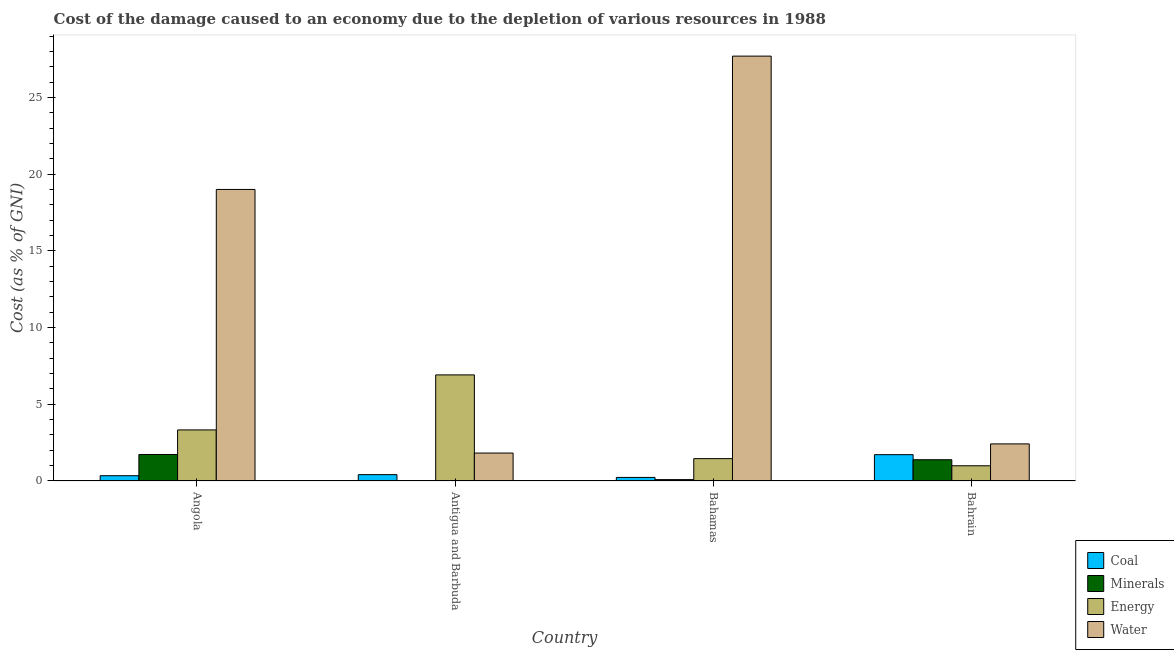How many different coloured bars are there?
Give a very brief answer. 4. How many groups of bars are there?
Keep it short and to the point. 4. Are the number of bars per tick equal to the number of legend labels?
Make the answer very short. Yes. Are the number of bars on each tick of the X-axis equal?
Ensure brevity in your answer.  Yes. What is the label of the 3rd group of bars from the left?
Your response must be concise. Bahamas. What is the cost of damage due to depletion of energy in Antigua and Barbuda?
Offer a very short reply. 6.92. Across all countries, what is the maximum cost of damage due to depletion of energy?
Offer a terse response. 6.92. Across all countries, what is the minimum cost of damage due to depletion of minerals?
Make the answer very short. 0.02. In which country was the cost of damage due to depletion of minerals maximum?
Your response must be concise. Angola. In which country was the cost of damage due to depletion of coal minimum?
Your answer should be compact. Bahamas. What is the total cost of damage due to depletion of energy in the graph?
Keep it short and to the point. 12.7. What is the difference between the cost of damage due to depletion of water in Angola and that in Bahamas?
Your answer should be compact. -8.69. What is the difference between the cost of damage due to depletion of minerals in Antigua and Barbuda and the cost of damage due to depletion of water in Bahamas?
Offer a terse response. -27.67. What is the average cost of damage due to depletion of energy per country?
Your answer should be compact. 3.17. What is the difference between the cost of damage due to depletion of energy and cost of damage due to depletion of coal in Angola?
Your answer should be compact. 2.99. In how many countries, is the cost of damage due to depletion of water greater than 23 %?
Make the answer very short. 1. What is the ratio of the cost of damage due to depletion of minerals in Angola to that in Bahrain?
Your response must be concise. 1.25. Is the cost of damage due to depletion of minerals in Angola less than that in Bahrain?
Ensure brevity in your answer.  No. What is the difference between the highest and the second highest cost of damage due to depletion of energy?
Your response must be concise. 3.59. What is the difference between the highest and the lowest cost of damage due to depletion of water?
Make the answer very short. 25.88. Is the sum of the cost of damage due to depletion of coal in Angola and Bahrain greater than the maximum cost of damage due to depletion of water across all countries?
Your answer should be compact. No. What does the 1st bar from the left in Antigua and Barbuda represents?
Your response must be concise. Coal. What does the 3rd bar from the right in Angola represents?
Keep it short and to the point. Minerals. Is it the case that in every country, the sum of the cost of damage due to depletion of coal and cost of damage due to depletion of minerals is greater than the cost of damage due to depletion of energy?
Ensure brevity in your answer.  No. How many countries are there in the graph?
Keep it short and to the point. 4. Does the graph contain any zero values?
Provide a short and direct response. No. How many legend labels are there?
Your answer should be compact. 4. How are the legend labels stacked?
Offer a terse response. Vertical. What is the title of the graph?
Provide a succinct answer. Cost of the damage caused to an economy due to the depletion of various resources in 1988 . Does "UNAIDS" appear as one of the legend labels in the graph?
Keep it short and to the point. No. What is the label or title of the Y-axis?
Provide a succinct answer. Cost (as % of GNI). What is the Cost (as % of GNI) in Coal in Angola?
Give a very brief answer. 0.34. What is the Cost (as % of GNI) in Minerals in Angola?
Offer a terse response. 1.73. What is the Cost (as % of GNI) in Energy in Angola?
Offer a terse response. 3.33. What is the Cost (as % of GNI) in Water in Angola?
Provide a succinct answer. 19.01. What is the Cost (as % of GNI) of Coal in Antigua and Barbuda?
Keep it short and to the point. 0.41. What is the Cost (as % of GNI) of Minerals in Antigua and Barbuda?
Your response must be concise. 0.02. What is the Cost (as % of GNI) in Energy in Antigua and Barbuda?
Your answer should be compact. 6.92. What is the Cost (as % of GNI) of Water in Antigua and Barbuda?
Give a very brief answer. 1.82. What is the Cost (as % of GNI) of Coal in Bahamas?
Keep it short and to the point. 0.23. What is the Cost (as % of GNI) of Minerals in Bahamas?
Provide a succinct answer. 0.09. What is the Cost (as % of GNI) in Energy in Bahamas?
Ensure brevity in your answer.  1.46. What is the Cost (as % of GNI) of Water in Bahamas?
Ensure brevity in your answer.  27.7. What is the Cost (as % of GNI) of Coal in Bahrain?
Make the answer very short. 1.72. What is the Cost (as % of GNI) in Minerals in Bahrain?
Provide a succinct answer. 1.39. What is the Cost (as % of GNI) of Energy in Bahrain?
Your response must be concise. 0.99. What is the Cost (as % of GNI) in Water in Bahrain?
Provide a succinct answer. 2.42. Across all countries, what is the maximum Cost (as % of GNI) in Coal?
Your response must be concise. 1.72. Across all countries, what is the maximum Cost (as % of GNI) of Minerals?
Offer a very short reply. 1.73. Across all countries, what is the maximum Cost (as % of GNI) of Energy?
Make the answer very short. 6.92. Across all countries, what is the maximum Cost (as % of GNI) of Water?
Keep it short and to the point. 27.7. Across all countries, what is the minimum Cost (as % of GNI) of Coal?
Your response must be concise. 0.23. Across all countries, what is the minimum Cost (as % of GNI) of Minerals?
Your answer should be very brief. 0.02. Across all countries, what is the minimum Cost (as % of GNI) of Energy?
Ensure brevity in your answer.  0.99. Across all countries, what is the minimum Cost (as % of GNI) of Water?
Ensure brevity in your answer.  1.82. What is the total Cost (as % of GNI) of Coal in the graph?
Ensure brevity in your answer.  2.71. What is the total Cost (as % of GNI) in Minerals in the graph?
Provide a succinct answer. 3.23. What is the total Cost (as % of GNI) of Energy in the graph?
Your answer should be compact. 12.7. What is the total Cost (as % of GNI) in Water in the graph?
Your response must be concise. 50.94. What is the difference between the Cost (as % of GNI) in Coal in Angola and that in Antigua and Barbuda?
Offer a terse response. -0.07. What is the difference between the Cost (as % of GNI) of Minerals in Angola and that in Antigua and Barbuda?
Provide a succinct answer. 1.7. What is the difference between the Cost (as % of GNI) of Energy in Angola and that in Antigua and Barbuda?
Provide a succinct answer. -3.59. What is the difference between the Cost (as % of GNI) in Water in Angola and that in Antigua and Barbuda?
Give a very brief answer. 17.18. What is the difference between the Cost (as % of GNI) of Coal in Angola and that in Bahamas?
Your answer should be very brief. 0.11. What is the difference between the Cost (as % of GNI) in Minerals in Angola and that in Bahamas?
Offer a very short reply. 1.64. What is the difference between the Cost (as % of GNI) of Energy in Angola and that in Bahamas?
Keep it short and to the point. 1.87. What is the difference between the Cost (as % of GNI) in Water in Angola and that in Bahamas?
Provide a succinct answer. -8.69. What is the difference between the Cost (as % of GNI) in Coal in Angola and that in Bahrain?
Offer a very short reply. -1.37. What is the difference between the Cost (as % of GNI) of Minerals in Angola and that in Bahrain?
Make the answer very short. 0.34. What is the difference between the Cost (as % of GNI) in Energy in Angola and that in Bahrain?
Your answer should be very brief. 2.34. What is the difference between the Cost (as % of GNI) of Water in Angola and that in Bahrain?
Provide a succinct answer. 16.59. What is the difference between the Cost (as % of GNI) in Coal in Antigua and Barbuda and that in Bahamas?
Keep it short and to the point. 0.18. What is the difference between the Cost (as % of GNI) in Minerals in Antigua and Barbuda and that in Bahamas?
Provide a short and direct response. -0.07. What is the difference between the Cost (as % of GNI) in Energy in Antigua and Barbuda and that in Bahamas?
Provide a succinct answer. 5.46. What is the difference between the Cost (as % of GNI) of Water in Antigua and Barbuda and that in Bahamas?
Your answer should be compact. -25.88. What is the difference between the Cost (as % of GNI) in Coal in Antigua and Barbuda and that in Bahrain?
Your answer should be compact. -1.3. What is the difference between the Cost (as % of GNI) of Minerals in Antigua and Barbuda and that in Bahrain?
Ensure brevity in your answer.  -1.36. What is the difference between the Cost (as % of GNI) in Energy in Antigua and Barbuda and that in Bahrain?
Ensure brevity in your answer.  5.92. What is the difference between the Cost (as % of GNI) in Water in Antigua and Barbuda and that in Bahrain?
Your answer should be compact. -0.6. What is the difference between the Cost (as % of GNI) in Coal in Bahamas and that in Bahrain?
Provide a short and direct response. -1.48. What is the difference between the Cost (as % of GNI) of Minerals in Bahamas and that in Bahrain?
Your response must be concise. -1.3. What is the difference between the Cost (as % of GNI) of Energy in Bahamas and that in Bahrain?
Ensure brevity in your answer.  0.47. What is the difference between the Cost (as % of GNI) of Water in Bahamas and that in Bahrain?
Give a very brief answer. 25.28. What is the difference between the Cost (as % of GNI) in Coal in Angola and the Cost (as % of GNI) in Minerals in Antigua and Barbuda?
Your response must be concise. 0.32. What is the difference between the Cost (as % of GNI) of Coal in Angola and the Cost (as % of GNI) of Energy in Antigua and Barbuda?
Provide a short and direct response. -6.57. What is the difference between the Cost (as % of GNI) of Coal in Angola and the Cost (as % of GNI) of Water in Antigua and Barbuda?
Provide a succinct answer. -1.48. What is the difference between the Cost (as % of GNI) of Minerals in Angola and the Cost (as % of GNI) of Energy in Antigua and Barbuda?
Your answer should be very brief. -5.19. What is the difference between the Cost (as % of GNI) in Minerals in Angola and the Cost (as % of GNI) in Water in Antigua and Barbuda?
Make the answer very short. -0.09. What is the difference between the Cost (as % of GNI) in Energy in Angola and the Cost (as % of GNI) in Water in Antigua and Barbuda?
Offer a terse response. 1.51. What is the difference between the Cost (as % of GNI) in Coal in Angola and the Cost (as % of GNI) in Minerals in Bahamas?
Make the answer very short. 0.26. What is the difference between the Cost (as % of GNI) of Coal in Angola and the Cost (as % of GNI) of Energy in Bahamas?
Provide a succinct answer. -1.11. What is the difference between the Cost (as % of GNI) in Coal in Angola and the Cost (as % of GNI) in Water in Bahamas?
Your answer should be very brief. -27.35. What is the difference between the Cost (as % of GNI) of Minerals in Angola and the Cost (as % of GNI) of Energy in Bahamas?
Offer a very short reply. 0.27. What is the difference between the Cost (as % of GNI) in Minerals in Angola and the Cost (as % of GNI) in Water in Bahamas?
Keep it short and to the point. -25.97. What is the difference between the Cost (as % of GNI) of Energy in Angola and the Cost (as % of GNI) of Water in Bahamas?
Ensure brevity in your answer.  -24.37. What is the difference between the Cost (as % of GNI) in Coal in Angola and the Cost (as % of GNI) in Minerals in Bahrain?
Provide a short and direct response. -1.04. What is the difference between the Cost (as % of GNI) in Coal in Angola and the Cost (as % of GNI) in Energy in Bahrain?
Offer a terse response. -0.65. What is the difference between the Cost (as % of GNI) of Coal in Angola and the Cost (as % of GNI) of Water in Bahrain?
Ensure brevity in your answer.  -2.07. What is the difference between the Cost (as % of GNI) of Minerals in Angola and the Cost (as % of GNI) of Energy in Bahrain?
Your answer should be compact. 0.74. What is the difference between the Cost (as % of GNI) of Minerals in Angola and the Cost (as % of GNI) of Water in Bahrain?
Give a very brief answer. -0.69. What is the difference between the Cost (as % of GNI) of Energy in Angola and the Cost (as % of GNI) of Water in Bahrain?
Offer a very short reply. 0.91. What is the difference between the Cost (as % of GNI) in Coal in Antigua and Barbuda and the Cost (as % of GNI) in Minerals in Bahamas?
Provide a short and direct response. 0.33. What is the difference between the Cost (as % of GNI) in Coal in Antigua and Barbuda and the Cost (as % of GNI) in Energy in Bahamas?
Make the answer very short. -1.04. What is the difference between the Cost (as % of GNI) of Coal in Antigua and Barbuda and the Cost (as % of GNI) of Water in Bahamas?
Give a very brief answer. -27.28. What is the difference between the Cost (as % of GNI) in Minerals in Antigua and Barbuda and the Cost (as % of GNI) in Energy in Bahamas?
Give a very brief answer. -1.43. What is the difference between the Cost (as % of GNI) in Minerals in Antigua and Barbuda and the Cost (as % of GNI) in Water in Bahamas?
Offer a very short reply. -27.67. What is the difference between the Cost (as % of GNI) of Energy in Antigua and Barbuda and the Cost (as % of GNI) of Water in Bahamas?
Ensure brevity in your answer.  -20.78. What is the difference between the Cost (as % of GNI) of Coal in Antigua and Barbuda and the Cost (as % of GNI) of Minerals in Bahrain?
Keep it short and to the point. -0.97. What is the difference between the Cost (as % of GNI) in Coal in Antigua and Barbuda and the Cost (as % of GNI) in Energy in Bahrain?
Provide a short and direct response. -0.58. What is the difference between the Cost (as % of GNI) of Coal in Antigua and Barbuda and the Cost (as % of GNI) of Water in Bahrain?
Your answer should be compact. -2. What is the difference between the Cost (as % of GNI) in Minerals in Antigua and Barbuda and the Cost (as % of GNI) in Energy in Bahrain?
Your answer should be very brief. -0.97. What is the difference between the Cost (as % of GNI) in Minerals in Antigua and Barbuda and the Cost (as % of GNI) in Water in Bahrain?
Make the answer very short. -2.39. What is the difference between the Cost (as % of GNI) in Energy in Antigua and Barbuda and the Cost (as % of GNI) in Water in Bahrain?
Give a very brief answer. 4.5. What is the difference between the Cost (as % of GNI) in Coal in Bahamas and the Cost (as % of GNI) in Minerals in Bahrain?
Your response must be concise. -1.15. What is the difference between the Cost (as % of GNI) in Coal in Bahamas and the Cost (as % of GNI) in Energy in Bahrain?
Your answer should be compact. -0.76. What is the difference between the Cost (as % of GNI) of Coal in Bahamas and the Cost (as % of GNI) of Water in Bahrain?
Offer a very short reply. -2.19. What is the difference between the Cost (as % of GNI) in Minerals in Bahamas and the Cost (as % of GNI) in Energy in Bahrain?
Provide a short and direct response. -0.9. What is the difference between the Cost (as % of GNI) in Minerals in Bahamas and the Cost (as % of GNI) in Water in Bahrain?
Your answer should be very brief. -2.33. What is the difference between the Cost (as % of GNI) in Energy in Bahamas and the Cost (as % of GNI) in Water in Bahrain?
Provide a short and direct response. -0.96. What is the average Cost (as % of GNI) of Coal per country?
Your answer should be compact. 0.68. What is the average Cost (as % of GNI) in Minerals per country?
Ensure brevity in your answer.  0.81. What is the average Cost (as % of GNI) of Energy per country?
Your response must be concise. 3.17. What is the average Cost (as % of GNI) of Water per country?
Offer a terse response. 12.74. What is the difference between the Cost (as % of GNI) of Coal and Cost (as % of GNI) of Minerals in Angola?
Your response must be concise. -1.38. What is the difference between the Cost (as % of GNI) in Coal and Cost (as % of GNI) in Energy in Angola?
Your answer should be compact. -2.99. What is the difference between the Cost (as % of GNI) of Coal and Cost (as % of GNI) of Water in Angola?
Your answer should be compact. -18.66. What is the difference between the Cost (as % of GNI) of Minerals and Cost (as % of GNI) of Energy in Angola?
Give a very brief answer. -1.6. What is the difference between the Cost (as % of GNI) in Minerals and Cost (as % of GNI) in Water in Angola?
Make the answer very short. -17.28. What is the difference between the Cost (as % of GNI) in Energy and Cost (as % of GNI) in Water in Angola?
Offer a terse response. -15.68. What is the difference between the Cost (as % of GNI) of Coal and Cost (as % of GNI) of Minerals in Antigua and Barbuda?
Provide a short and direct response. 0.39. What is the difference between the Cost (as % of GNI) in Coal and Cost (as % of GNI) in Energy in Antigua and Barbuda?
Make the answer very short. -6.5. What is the difference between the Cost (as % of GNI) in Coal and Cost (as % of GNI) in Water in Antigua and Barbuda?
Your answer should be compact. -1.41. What is the difference between the Cost (as % of GNI) in Minerals and Cost (as % of GNI) in Energy in Antigua and Barbuda?
Offer a terse response. -6.89. What is the difference between the Cost (as % of GNI) of Minerals and Cost (as % of GNI) of Water in Antigua and Barbuda?
Provide a short and direct response. -1.8. What is the difference between the Cost (as % of GNI) in Energy and Cost (as % of GNI) in Water in Antigua and Barbuda?
Make the answer very short. 5.09. What is the difference between the Cost (as % of GNI) in Coal and Cost (as % of GNI) in Minerals in Bahamas?
Give a very brief answer. 0.14. What is the difference between the Cost (as % of GNI) in Coal and Cost (as % of GNI) in Energy in Bahamas?
Give a very brief answer. -1.23. What is the difference between the Cost (as % of GNI) of Coal and Cost (as % of GNI) of Water in Bahamas?
Offer a very short reply. -27.46. What is the difference between the Cost (as % of GNI) of Minerals and Cost (as % of GNI) of Energy in Bahamas?
Ensure brevity in your answer.  -1.37. What is the difference between the Cost (as % of GNI) of Minerals and Cost (as % of GNI) of Water in Bahamas?
Your response must be concise. -27.61. What is the difference between the Cost (as % of GNI) in Energy and Cost (as % of GNI) in Water in Bahamas?
Make the answer very short. -26.24. What is the difference between the Cost (as % of GNI) in Coal and Cost (as % of GNI) in Minerals in Bahrain?
Offer a terse response. 0.33. What is the difference between the Cost (as % of GNI) of Coal and Cost (as % of GNI) of Energy in Bahrain?
Your answer should be very brief. 0.72. What is the difference between the Cost (as % of GNI) in Coal and Cost (as % of GNI) in Water in Bahrain?
Your answer should be compact. -0.7. What is the difference between the Cost (as % of GNI) in Minerals and Cost (as % of GNI) in Energy in Bahrain?
Ensure brevity in your answer.  0.39. What is the difference between the Cost (as % of GNI) of Minerals and Cost (as % of GNI) of Water in Bahrain?
Keep it short and to the point. -1.03. What is the difference between the Cost (as % of GNI) in Energy and Cost (as % of GNI) in Water in Bahrain?
Keep it short and to the point. -1.43. What is the ratio of the Cost (as % of GNI) in Coal in Angola to that in Antigua and Barbuda?
Make the answer very short. 0.83. What is the ratio of the Cost (as % of GNI) of Minerals in Angola to that in Antigua and Barbuda?
Keep it short and to the point. 73.9. What is the ratio of the Cost (as % of GNI) in Energy in Angola to that in Antigua and Barbuda?
Your answer should be very brief. 0.48. What is the ratio of the Cost (as % of GNI) in Water in Angola to that in Antigua and Barbuda?
Provide a succinct answer. 10.44. What is the ratio of the Cost (as % of GNI) in Coal in Angola to that in Bahamas?
Provide a succinct answer. 1.48. What is the ratio of the Cost (as % of GNI) of Minerals in Angola to that in Bahamas?
Ensure brevity in your answer.  19.24. What is the ratio of the Cost (as % of GNI) of Energy in Angola to that in Bahamas?
Make the answer very short. 2.28. What is the ratio of the Cost (as % of GNI) of Water in Angola to that in Bahamas?
Keep it short and to the point. 0.69. What is the ratio of the Cost (as % of GNI) in Coal in Angola to that in Bahrain?
Your response must be concise. 0.2. What is the ratio of the Cost (as % of GNI) of Minerals in Angola to that in Bahrain?
Your answer should be very brief. 1.25. What is the ratio of the Cost (as % of GNI) of Energy in Angola to that in Bahrain?
Your answer should be very brief. 3.36. What is the ratio of the Cost (as % of GNI) of Water in Angola to that in Bahrain?
Provide a succinct answer. 7.86. What is the ratio of the Cost (as % of GNI) of Coal in Antigua and Barbuda to that in Bahamas?
Provide a succinct answer. 1.78. What is the ratio of the Cost (as % of GNI) of Minerals in Antigua and Barbuda to that in Bahamas?
Your answer should be compact. 0.26. What is the ratio of the Cost (as % of GNI) in Energy in Antigua and Barbuda to that in Bahamas?
Provide a succinct answer. 4.74. What is the ratio of the Cost (as % of GNI) in Water in Antigua and Barbuda to that in Bahamas?
Give a very brief answer. 0.07. What is the ratio of the Cost (as % of GNI) of Coal in Antigua and Barbuda to that in Bahrain?
Provide a short and direct response. 0.24. What is the ratio of the Cost (as % of GNI) in Minerals in Antigua and Barbuda to that in Bahrain?
Your answer should be compact. 0.02. What is the ratio of the Cost (as % of GNI) of Energy in Antigua and Barbuda to that in Bahrain?
Keep it short and to the point. 6.97. What is the ratio of the Cost (as % of GNI) in Water in Antigua and Barbuda to that in Bahrain?
Your response must be concise. 0.75. What is the ratio of the Cost (as % of GNI) of Coal in Bahamas to that in Bahrain?
Offer a terse response. 0.14. What is the ratio of the Cost (as % of GNI) of Minerals in Bahamas to that in Bahrain?
Provide a short and direct response. 0.06. What is the ratio of the Cost (as % of GNI) of Energy in Bahamas to that in Bahrain?
Give a very brief answer. 1.47. What is the ratio of the Cost (as % of GNI) of Water in Bahamas to that in Bahrain?
Give a very brief answer. 11.45. What is the difference between the highest and the second highest Cost (as % of GNI) of Coal?
Keep it short and to the point. 1.3. What is the difference between the highest and the second highest Cost (as % of GNI) of Minerals?
Give a very brief answer. 0.34. What is the difference between the highest and the second highest Cost (as % of GNI) of Energy?
Your answer should be very brief. 3.59. What is the difference between the highest and the second highest Cost (as % of GNI) in Water?
Make the answer very short. 8.69. What is the difference between the highest and the lowest Cost (as % of GNI) in Coal?
Keep it short and to the point. 1.48. What is the difference between the highest and the lowest Cost (as % of GNI) in Minerals?
Make the answer very short. 1.7. What is the difference between the highest and the lowest Cost (as % of GNI) of Energy?
Your answer should be compact. 5.92. What is the difference between the highest and the lowest Cost (as % of GNI) of Water?
Give a very brief answer. 25.88. 